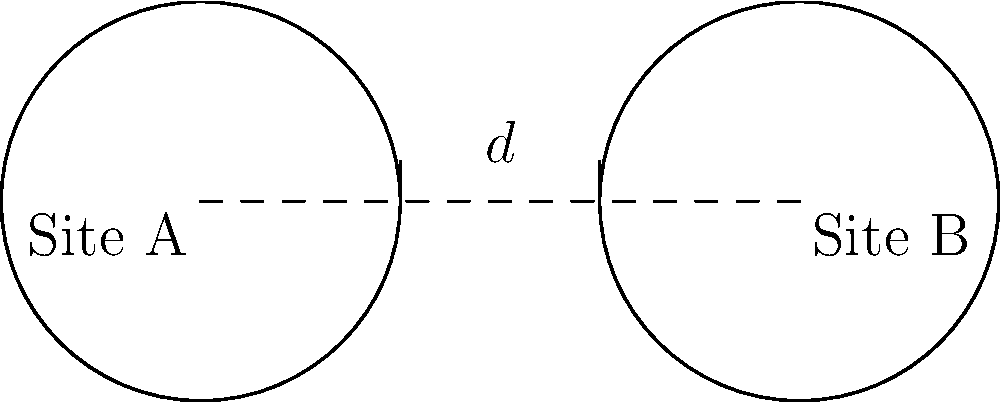Two circular stone arrangements have been discovered at archaeological sites A and B. Both circles have a radius of 10 meters, and their centers are 30 meters apart. Are these circular arrangements congruent? If so, explain why. To determine if the circular stone arrangements are congruent, we need to follow these steps:

1. Recall the definition of congruent circles: Two circles are congruent if and only if they have the same radius.

2. Analyze the given information:
   - Both circles have a radius of 10 meters.
   - The distance between their centers is 30 meters (this information is not relevant for congruence).

3. Compare the radii:
   - Circle at Site A: radius = 10 meters
   - Circle at Site B: radius = 10 meters

4. Since both circles have the same radius (10 meters), they are congruent.

5. The distance between the centers (30 meters) does not affect the congruence of the circles. It only determines their relative position.

6. In mathematical terms, we can express this as:
   $r_A = r_B = 10$ meters, where $r_A$ and $r_B$ are the radii of circles A and B respectively.

Therefore, the circular stone arrangements at sites A and B are congruent because they have the same radius, regardless of the distance between their centers.
Answer: Yes, congruent (same radius). 